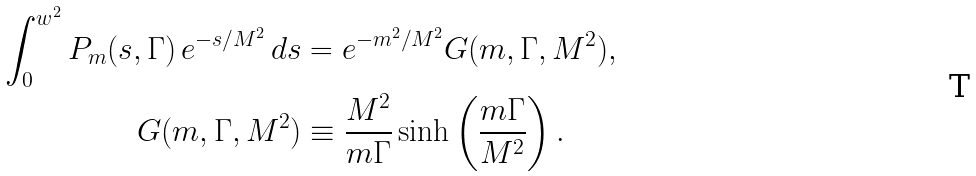Convert formula to latex. <formula><loc_0><loc_0><loc_500><loc_500>\int ^ { w ^ { 2 } } _ { 0 } P _ { m } ( s , \Gamma ) \, e ^ { - s / M ^ { 2 } } \, d s & = e ^ { - m ^ { 2 } / M ^ { 2 } } G ( m , \Gamma , M ^ { 2 } ) , \\ G ( m , \Gamma , M ^ { 2 } ) & \equiv \frac { M ^ { 2 } } { m \Gamma } \sinh \left ( \frac { m \Gamma } { M ^ { 2 } } \right ) .</formula> 